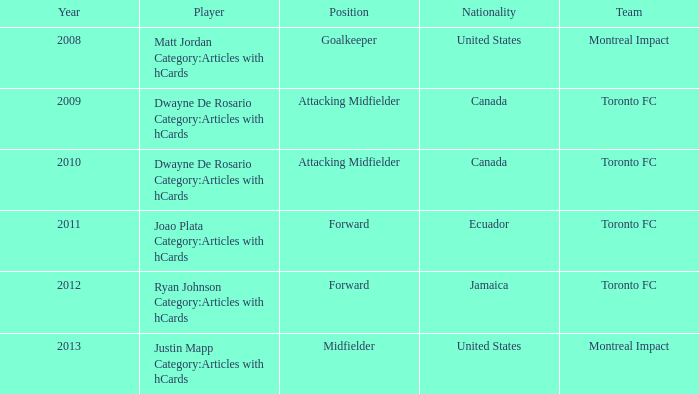What is the nationality of dwayne de rosario, a player mentioned in articles with hcards, after 2009? Canada. 